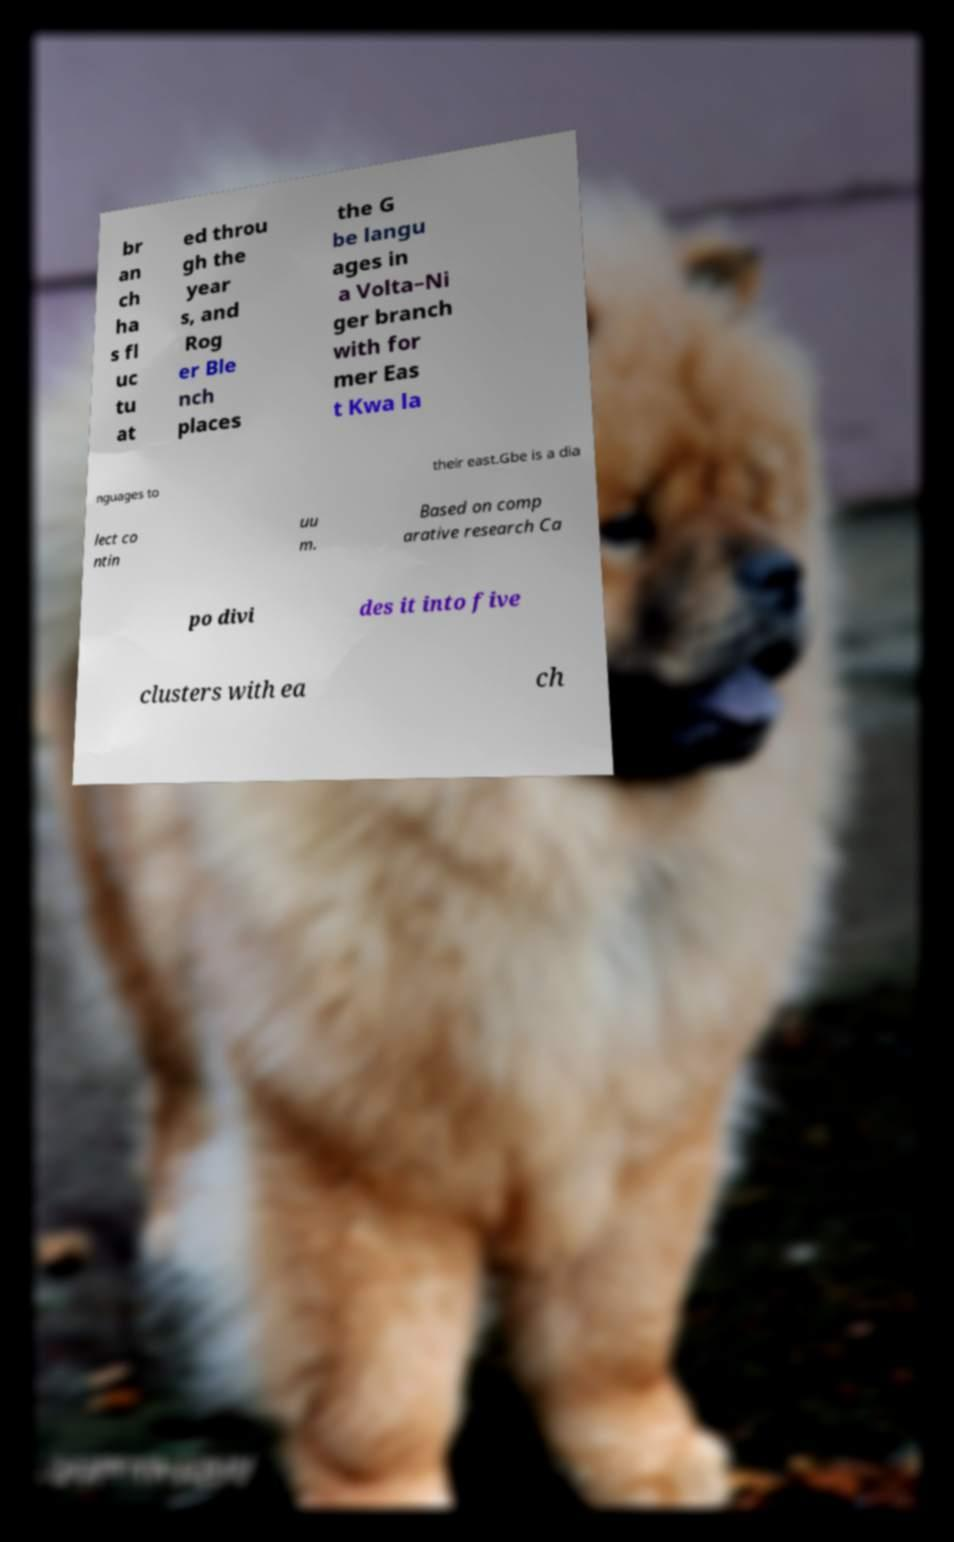Can you accurately transcribe the text from the provided image for me? br an ch ha s fl uc tu at ed throu gh the year s, and Rog er Ble nch places the G be langu ages in a Volta–Ni ger branch with for mer Eas t Kwa la nguages to their east.Gbe is a dia lect co ntin uu m. Based on comp arative research Ca po divi des it into five clusters with ea ch 